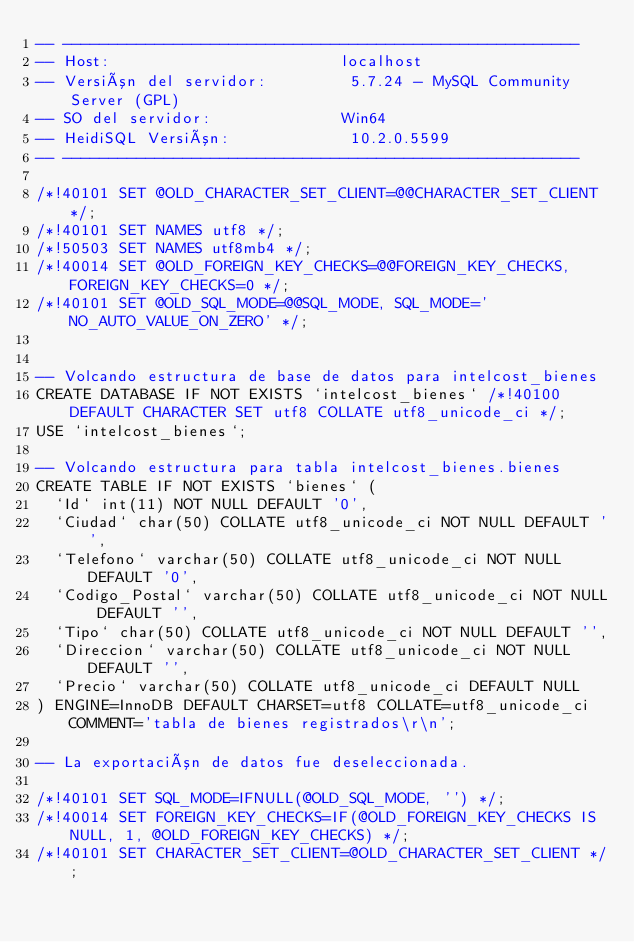Convert code to text. <code><loc_0><loc_0><loc_500><loc_500><_SQL_>-- --------------------------------------------------------
-- Host:                         localhost
-- Versión del servidor:         5.7.24 - MySQL Community Server (GPL)
-- SO del servidor:              Win64
-- HeidiSQL Versión:             10.2.0.5599
-- --------------------------------------------------------

/*!40101 SET @OLD_CHARACTER_SET_CLIENT=@@CHARACTER_SET_CLIENT */;
/*!40101 SET NAMES utf8 */;
/*!50503 SET NAMES utf8mb4 */;
/*!40014 SET @OLD_FOREIGN_KEY_CHECKS=@@FOREIGN_KEY_CHECKS, FOREIGN_KEY_CHECKS=0 */;
/*!40101 SET @OLD_SQL_MODE=@@SQL_MODE, SQL_MODE='NO_AUTO_VALUE_ON_ZERO' */;


-- Volcando estructura de base de datos para intelcost_bienes
CREATE DATABASE IF NOT EXISTS `intelcost_bienes` /*!40100 DEFAULT CHARACTER SET utf8 COLLATE utf8_unicode_ci */;
USE `intelcost_bienes`;

-- Volcando estructura para tabla intelcost_bienes.bienes
CREATE TABLE IF NOT EXISTS `bienes` (
  `Id` int(11) NOT NULL DEFAULT '0',
  `Ciudad` char(50) COLLATE utf8_unicode_ci NOT NULL DEFAULT '',
  `Telefono` varchar(50) COLLATE utf8_unicode_ci NOT NULL DEFAULT '0',
  `Codigo_Postal` varchar(50) COLLATE utf8_unicode_ci NOT NULL DEFAULT '',
  `Tipo` char(50) COLLATE utf8_unicode_ci NOT NULL DEFAULT '',
  `Direccion` varchar(50) COLLATE utf8_unicode_ci NOT NULL DEFAULT '',
  `Precio` varchar(50) COLLATE utf8_unicode_ci DEFAULT NULL
) ENGINE=InnoDB DEFAULT CHARSET=utf8 COLLATE=utf8_unicode_ci COMMENT='tabla de bienes registrados\r\n';

-- La exportación de datos fue deseleccionada.

/*!40101 SET SQL_MODE=IFNULL(@OLD_SQL_MODE, '') */;
/*!40014 SET FOREIGN_KEY_CHECKS=IF(@OLD_FOREIGN_KEY_CHECKS IS NULL, 1, @OLD_FOREIGN_KEY_CHECKS) */;
/*!40101 SET CHARACTER_SET_CLIENT=@OLD_CHARACTER_SET_CLIENT */;
</code> 